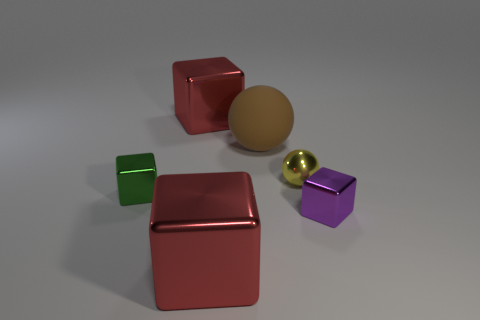Is the number of purple metallic objects that are behind the tiny ball less than the number of yellow matte spheres?
Make the answer very short. No. Are there more big objects that are behind the large brown rubber ball than yellow things behind the metal sphere?
Provide a succinct answer. Yes. Is there any other thing that has the same color as the rubber object?
Your response must be concise. No. There is a block that is on the right side of the yellow ball; what material is it?
Ensure brevity in your answer.  Metal. Is the size of the brown thing the same as the metal ball?
Ensure brevity in your answer.  No. How many other objects are the same size as the matte thing?
Provide a succinct answer. 2. Is the color of the big rubber sphere the same as the tiny shiny ball?
Make the answer very short. No. The big red thing to the left of the large red metallic cube on the right side of the block behind the big ball is what shape?
Ensure brevity in your answer.  Cube. How many things are small objects that are on the right side of the yellow metallic object or objects that are to the right of the green cube?
Provide a short and direct response. 5. There is a red cube that is behind the tiny green cube to the left of the small purple metal object; what is its size?
Offer a very short reply. Large. 